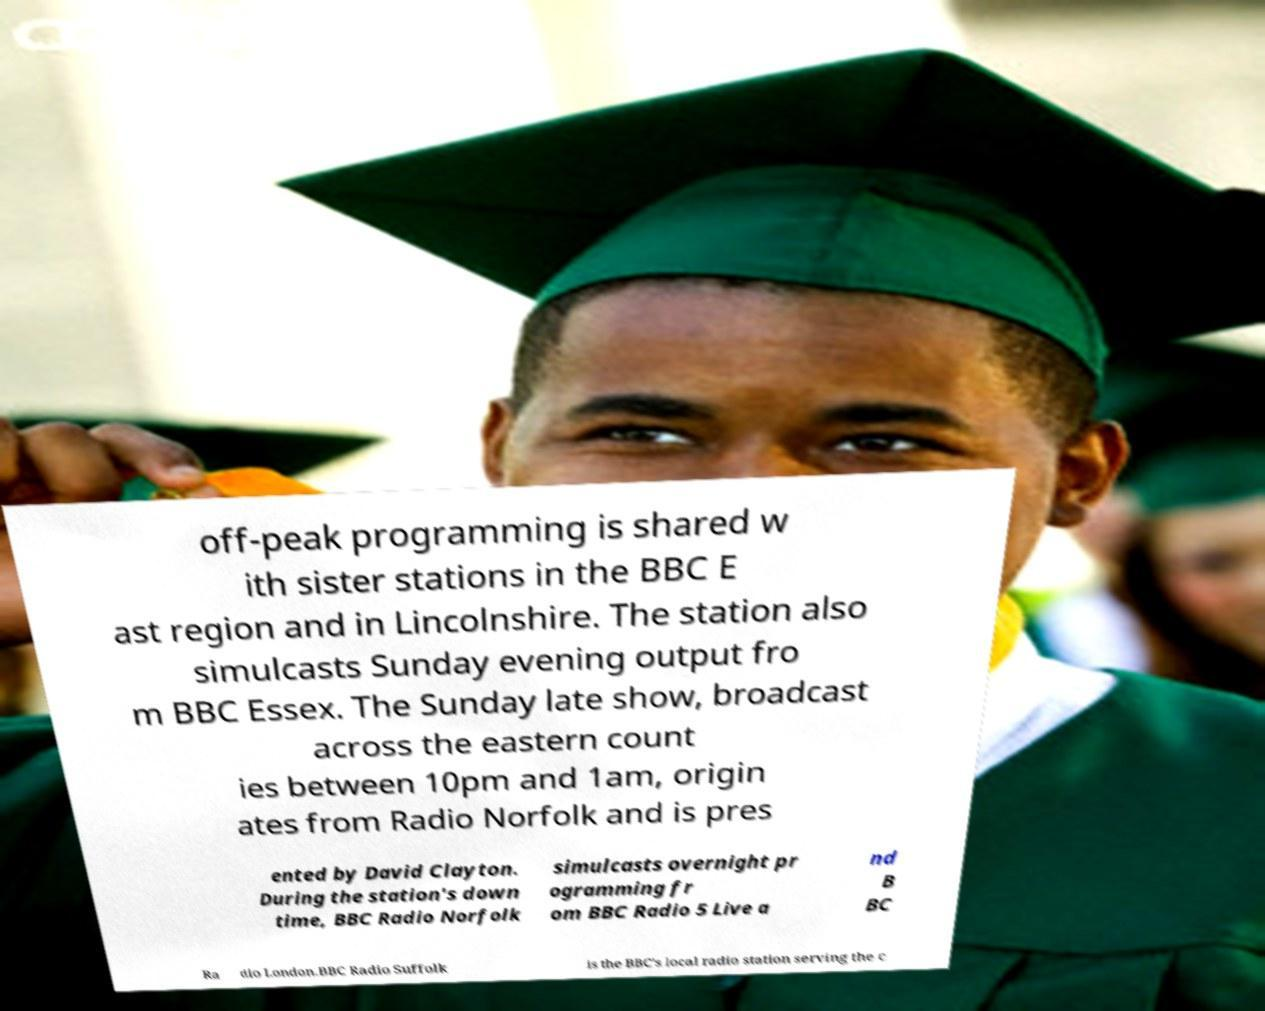Could you assist in decoding the text presented in this image and type it out clearly? off-peak programming is shared w ith sister stations in the BBC E ast region and in Lincolnshire. The station also simulcasts Sunday evening output fro m BBC Essex. The Sunday late show, broadcast across the eastern count ies between 10pm and 1am, origin ates from Radio Norfolk and is pres ented by David Clayton. During the station's down time, BBC Radio Norfolk simulcasts overnight pr ogramming fr om BBC Radio 5 Live a nd B BC Ra dio London.BBC Radio Suffolk is the BBC's local radio station serving the c 